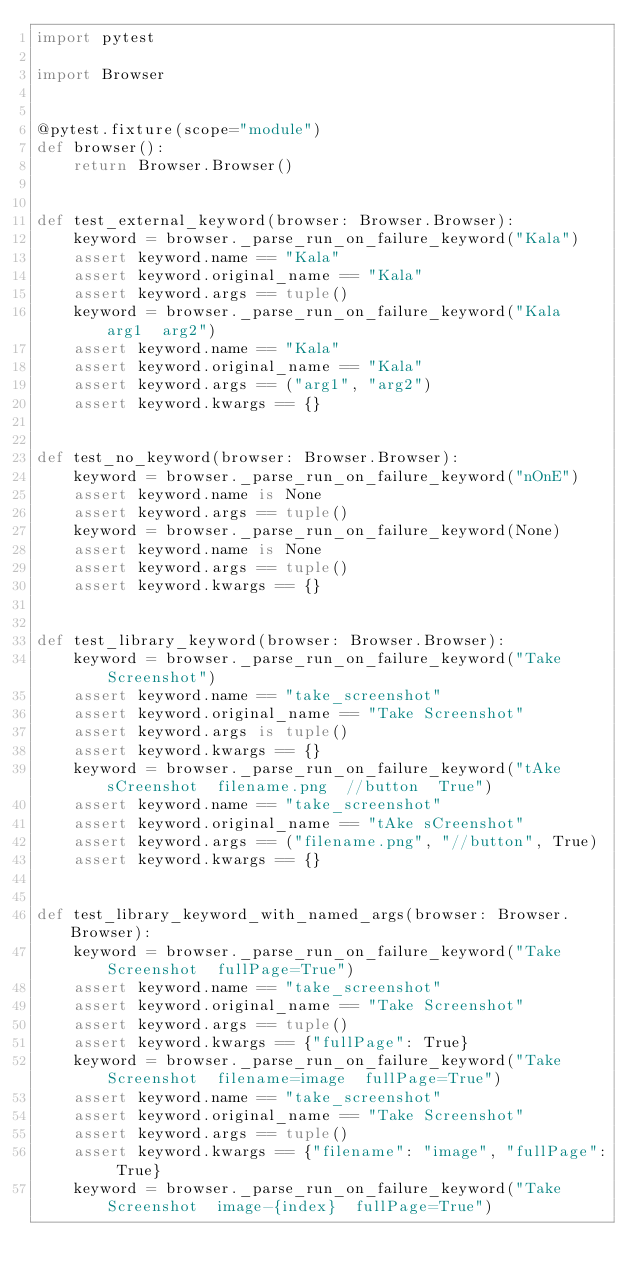Convert code to text. <code><loc_0><loc_0><loc_500><loc_500><_Python_>import pytest

import Browser


@pytest.fixture(scope="module")
def browser():
    return Browser.Browser()


def test_external_keyword(browser: Browser.Browser):
    keyword = browser._parse_run_on_failure_keyword("Kala")
    assert keyword.name == "Kala"
    assert keyword.original_name == "Kala"
    assert keyword.args == tuple()
    keyword = browser._parse_run_on_failure_keyword("Kala  arg1  arg2")
    assert keyword.name == "Kala"
    assert keyword.original_name == "Kala"
    assert keyword.args == ("arg1", "arg2")
    assert keyword.kwargs == {}


def test_no_keyword(browser: Browser.Browser):
    keyword = browser._parse_run_on_failure_keyword("nOnE")
    assert keyword.name is None
    assert keyword.args == tuple()
    keyword = browser._parse_run_on_failure_keyword(None)
    assert keyword.name is None
    assert keyword.args == tuple()
    assert keyword.kwargs == {}


def test_library_keyword(browser: Browser.Browser):
    keyword = browser._parse_run_on_failure_keyword("Take Screenshot")
    assert keyword.name == "take_screenshot"
    assert keyword.original_name == "Take Screenshot"
    assert keyword.args is tuple()
    assert keyword.kwargs == {}
    keyword = browser._parse_run_on_failure_keyword("tAke sCreenshot  filename.png  //button  True")
    assert keyword.name == "take_screenshot"
    assert keyword.original_name == "tAke sCreenshot"
    assert keyword.args == ("filename.png", "//button", True)
    assert keyword.kwargs == {}


def test_library_keyword_with_named_args(browser: Browser.Browser):
    keyword = browser._parse_run_on_failure_keyword("Take Screenshot  fullPage=True")
    assert keyword.name == "take_screenshot"
    assert keyword.original_name == "Take Screenshot"
    assert keyword.args == tuple()
    assert keyword.kwargs == {"fullPage": True}
    keyword = browser._parse_run_on_failure_keyword("Take Screenshot  filename=image  fullPage=True")
    assert keyword.name == "take_screenshot"
    assert keyword.original_name == "Take Screenshot"
    assert keyword.args == tuple()
    assert keyword.kwargs == {"filename": "image", "fullPage": True}
    keyword = browser._parse_run_on_failure_keyword("Take Screenshot  image-{index}  fullPage=True")</code> 